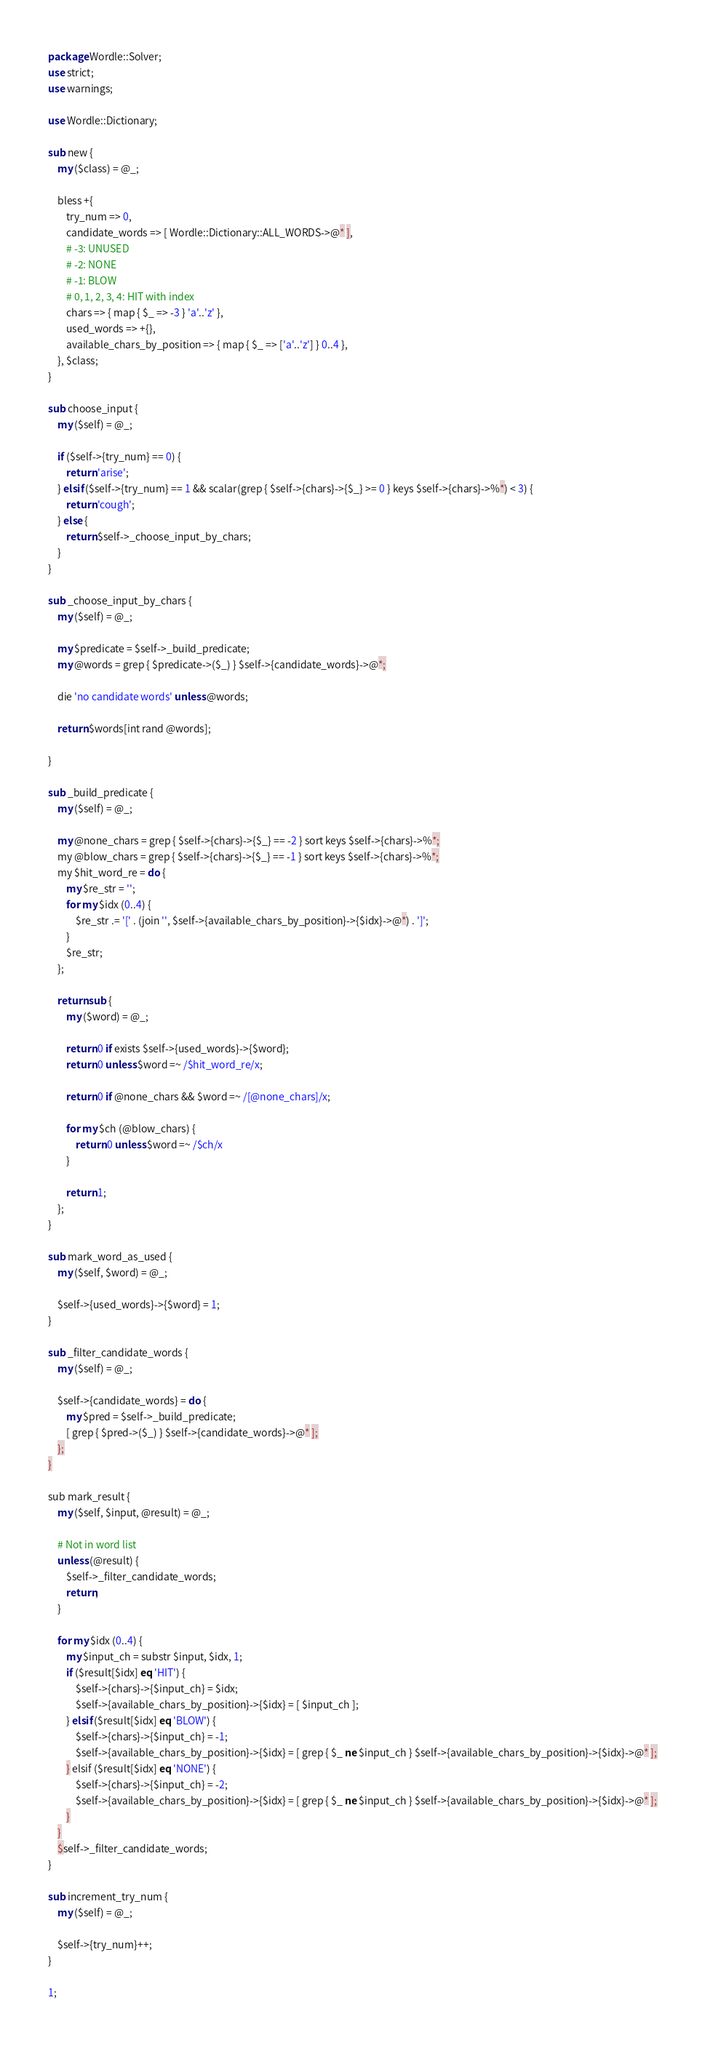<code> <loc_0><loc_0><loc_500><loc_500><_Perl_>package Wordle::Solver;
use strict;
use warnings;

use Wordle::Dictionary;

sub new {
    my ($class) = @_;

    bless +{
        try_num => 0,
        candidate_words => [ Wordle::Dictionary::ALL_WORDS->@* ],
        # -3: UNUSED
        # -2: NONE
        # -1: BLOW
        # 0, 1, 2, 3, 4: HIT with index
        chars => { map { $_ => -3 } 'a'..'z' },
        used_words => +{},
        available_chars_by_position => { map { $_ => ['a'..'z'] } 0..4 },
    }, $class;
}

sub choose_input {
    my ($self) = @_;

    if ($self->{try_num} == 0) {
        return 'arise';
    } elsif ($self->{try_num} == 1 && scalar(grep { $self->{chars}->{$_} >= 0 } keys $self->{chars}->%*) < 3) {
        return 'cough';
    } else {
        return $self->_choose_input_by_chars;
    }
}

sub _choose_input_by_chars {
    my ($self) = @_;

    my $predicate = $self->_build_predicate;
    my @words = grep { $predicate->($_) } $self->{candidate_words}->@*;

    die 'no candidate words' unless @words;

    return $words[int rand @words];

}

sub _build_predicate {
    my ($self) = @_;

    my @none_chars = grep { $self->{chars}->{$_} == -2 } sort keys $self->{chars}->%*;
    my @blow_chars = grep { $self->{chars}->{$_} == -1 } sort keys $self->{chars}->%*;
    my $hit_word_re = do {
        my $re_str = '';
        for my $idx (0..4) {
            $re_str .= '[' . (join '', $self->{available_chars_by_position}->{$idx}->@*) . ']';
        }
        $re_str;
    };

    return sub {
        my ($word) = @_;

        return 0 if exists $self->{used_words}->{$word};
        return 0 unless $word =~ /$hit_word_re/x;

        return 0 if @none_chars && $word =~ /[@none_chars]/x;

        for my $ch (@blow_chars) {
            return 0 unless $word =~ /$ch/x
        }

        return 1;
    };
}

sub mark_word_as_used {
    my ($self, $word) = @_;

    $self->{used_words}->{$word} = 1;
}

sub _filter_candidate_words {
    my ($self) = @_;

    $self->{candidate_words} = do {
        my $pred = $self->_build_predicate;
        [ grep { $pred->($_) } $self->{candidate_words}->@* ];
    };
}

sub mark_result {
    my ($self, $input, @result) = @_;

    # Not in word list
    unless (@result) {
        $self->_filter_candidate_words;
        return;
    }

    for my $idx (0..4) {
        my $input_ch = substr $input, $idx, 1;
        if ($result[$idx] eq 'HIT') {
            $self->{chars}->{$input_ch} = $idx;
            $self->{available_chars_by_position}->{$idx} = [ $input_ch ];
        } elsif ($result[$idx] eq 'BLOW') {
            $self->{chars}->{$input_ch} = -1;
            $self->{available_chars_by_position}->{$idx} = [ grep { $_ ne $input_ch } $self->{available_chars_by_position}->{$idx}->@* ];
        } elsif ($result[$idx] eq 'NONE') {
            $self->{chars}->{$input_ch} = -2;
            $self->{available_chars_by_position}->{$idx} = [ grep { $_ ne $input_ch } $self->{available_chars_by_position}->{$idx}->@* ];
        }
    }
    $self->_filter_candidate_words;
}

sub increment_try_num {
    my ($self) = @_;

    $self->{try_num}++;
}

1;
</code> 